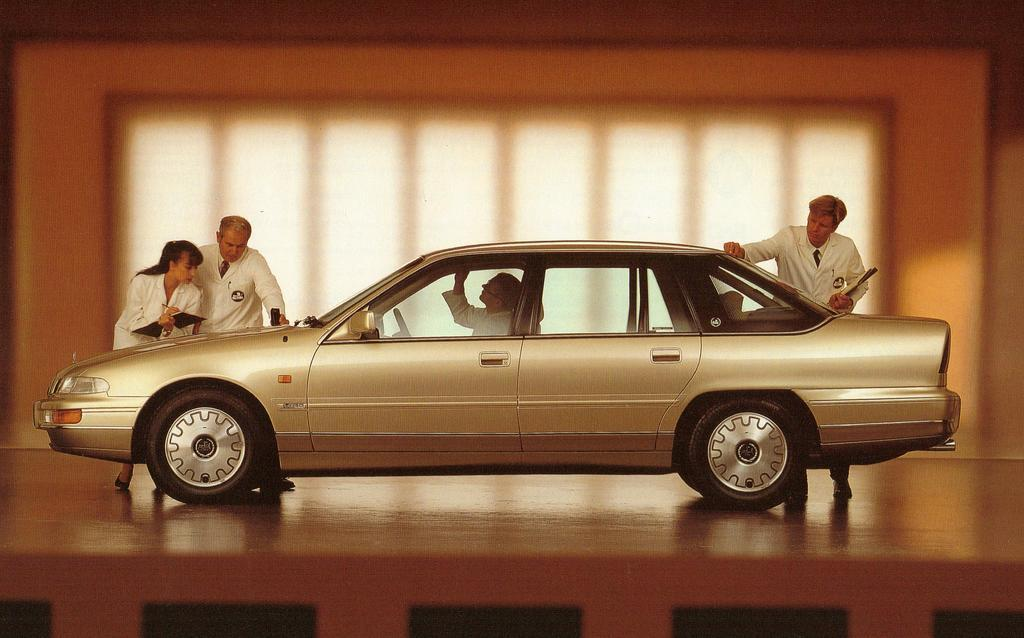What is the main subject of the image? The main subject of the image is the persons in the center. What are the persons doing in the image? The persons are at a car. What can be seen in the background of the image? There is a wall in the background of the image. What type of ink is being used to write on the car in the image? There is no ink or writing on the car in the image. What historical event is being commemorated by the persons in the image? There is no indication of a historical event or commemoration in the image. 